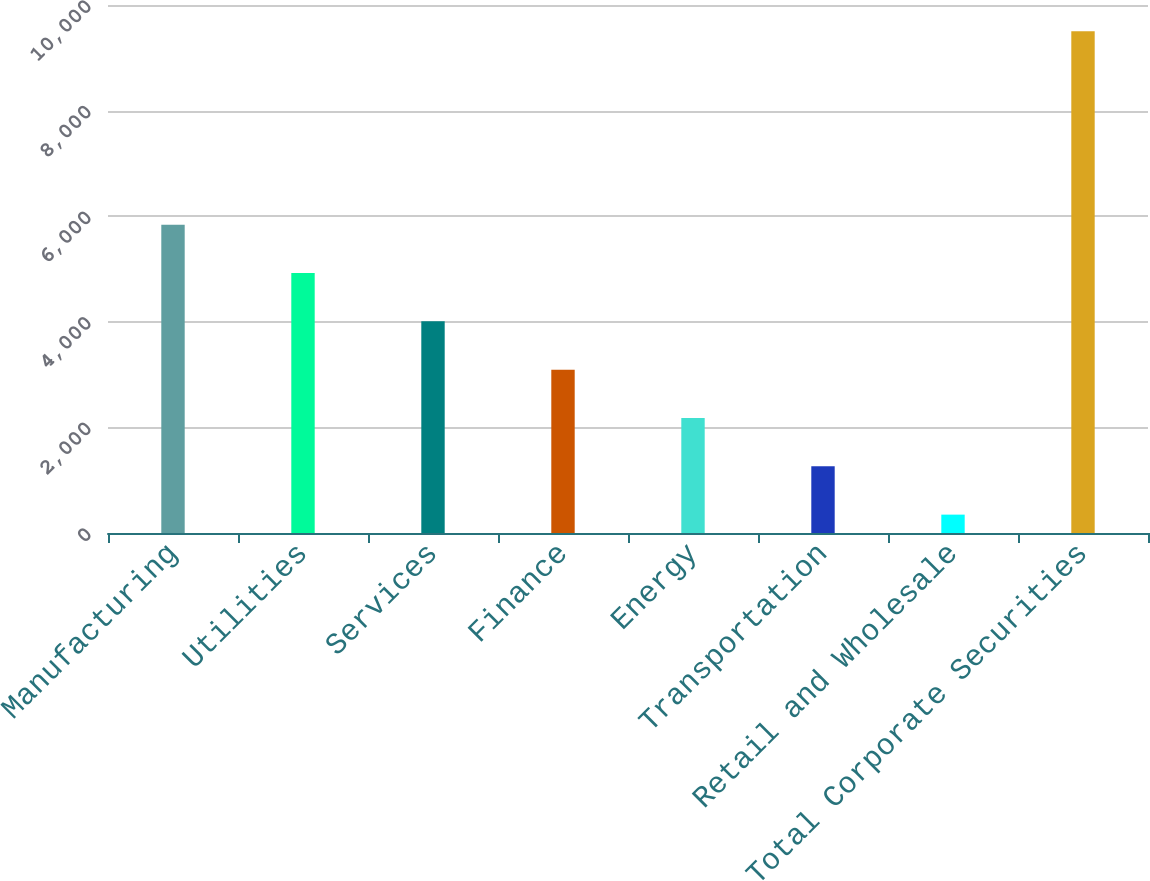Convert chart. <chart><loc_0><loc_0><loc_500><loc_500><bar_chart><fcel>Manufacturing<fcel>Utilities<fcel>Services<fcel>Finance<fcel>Energy<fcel>Transportation<fcel>Retail and Wholesale<fcel>Total Corporate Securities<nl><fcel>5840.4<fcel>4925<fcel>4009.6<fcel>3094.2<fcel>2178.8<fcel>1263.4<fcel>348<fcel>9502<nl></chart> 